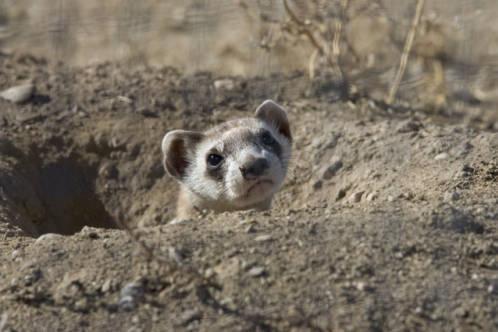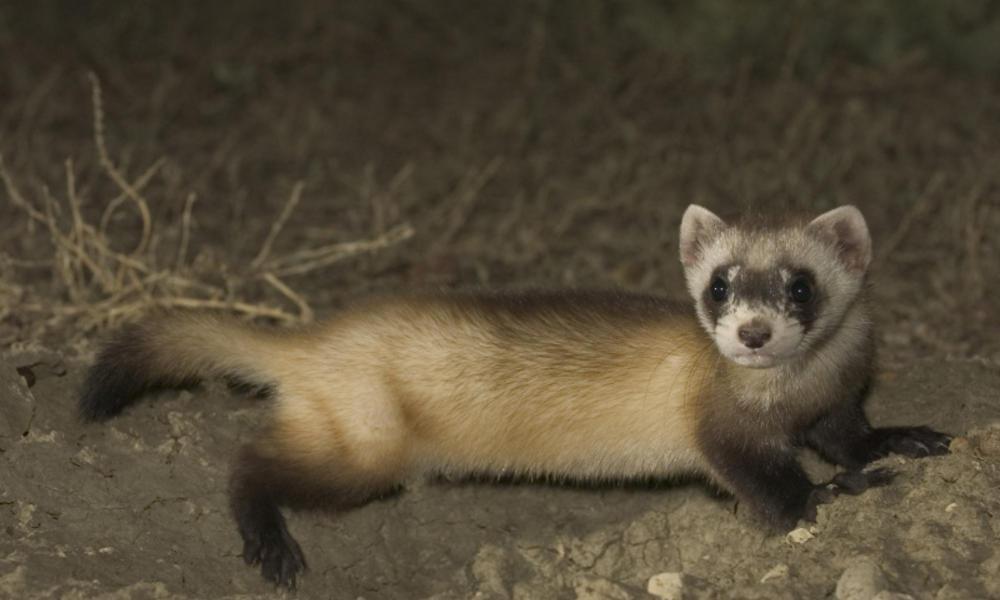The first image is the image on the left, the second image is the image on the right. Examine the images to the left and right. Is the description "In one of the images, the weasel's body is turned to the right, and in the other, it's turned to the left." accurate? Answer yes or no. No. 